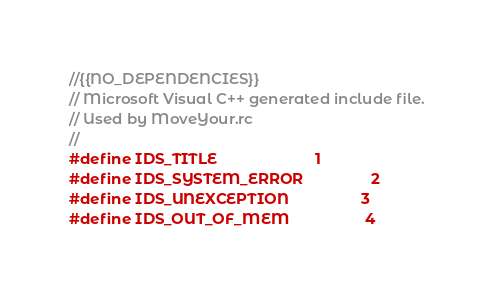<code> <loc_0><loc_0><loc_500><loc_500><_C_>//{{NO_DEPENDENCIES}}
// Microsoft Visual C++ generated include file.
// Used by MoveYour.rc
//
#define IDS_TITLE                       1
#define IDS_SYSTEM_ERROR                2
#define IDS_UNEXCEPTION                 3
#define IDS_OUT_OF_MEM                  4</code> 